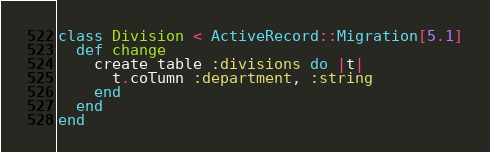Convert code to text. <code><loc_0><loc_0><loc_500><loc_500><_Ruby_>
class Division < ActiveRecord::Migration[5.1]
  def change
    create_table :divisions do |t|
      t.column :department, :string
    end
  end
end
</code> 